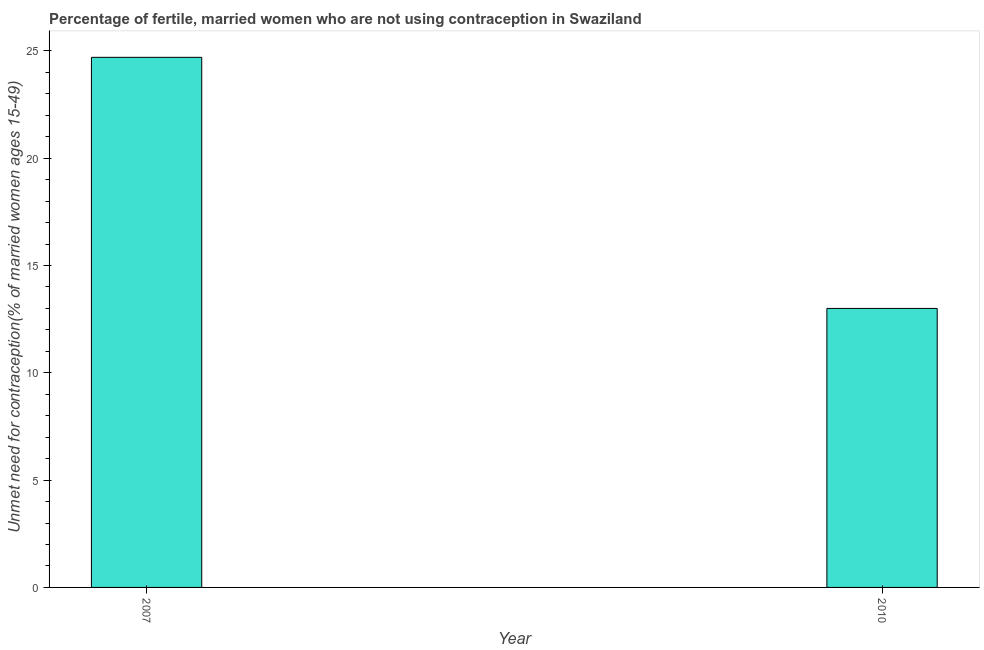Does the graph contain any zero values?
Keep it short and to the point. No. What is the title of the graph?
Offer a very short reply. Percentage of fertile, married women who are not using contraception in Swaziland. What is the label or title of the Y-axis?
Provide a short and direct response.  Unmet need for contraception(% of married women ages 15-49). What is the number of married women who are not using contraception in 2007?
Keep it short and to the point. 24.7. Across all years, what is the maximum number of married women who are not using contraception?
Your answer should be very brief. 24.7. What is the sum of the number of married women who are not using contraception?
Your answer should be very brief. 37.7. What is the average number of married women who are not using contraception per year?
Make the answer very short. 18.85. What is the median number of married women who are not using contraception?
Your answer should be very brief. 18.85. In how many years, is the number of married women who are not using contraception greater than 17 %?
Offer a terse response. 1. What is the ratio of the number of married women who are not using contraception in 2007 to that in 2010?
Your answer should be very brief. 1.9. In how many years, is the number of married women who are not using contraception greater than the average number of married women who are not using contraception taken over all years?
Provide a short and direct response. 1. How many bars are there?
Give a very brief answer. 2. How many years are there in the graph?
Offer a very short reply. 2. What is the difference between two consecutive major ticks on the Y-axis?
Your answer should be very brief. 5. What is the  Unmet need for contraception(% of married women ages 15-49) of 2007?
Offer a terse response. 24.7. What is the  Unmet need for contraception(% of married women ages 15-49) of 2010?
Offer a very short reply. 13. What is the ratio of the  Unmet need for contraception(% of married women ages 15-49) in 2007 to that in 2010?
Give a very brief answer. 1.9. 